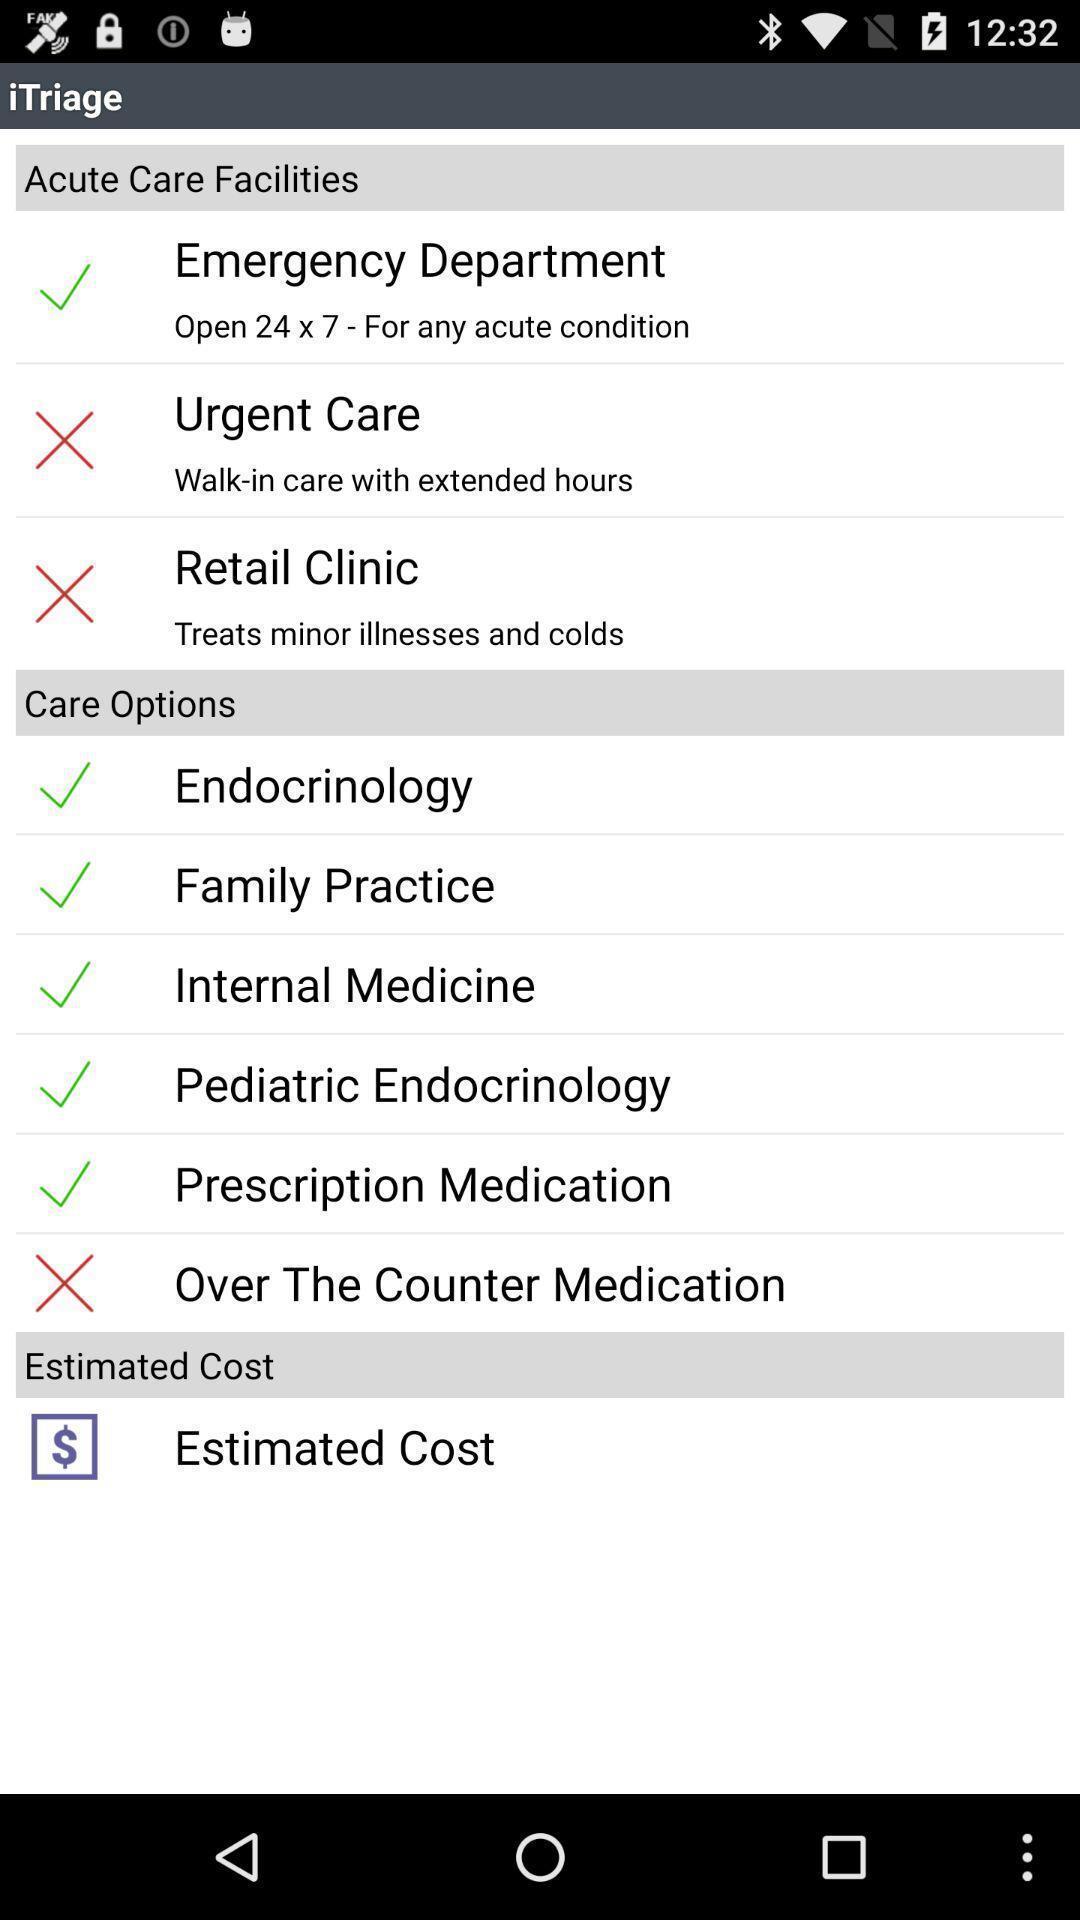Summarize the main components in this picture. Window displaying a health care app. 